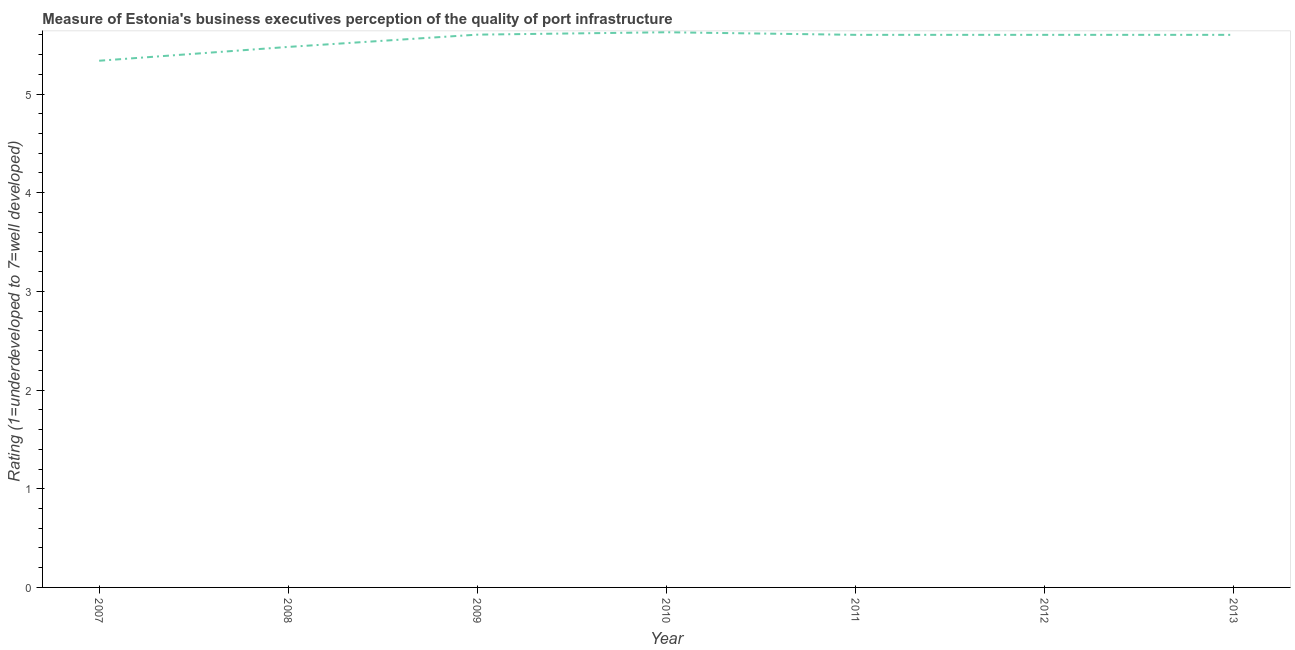What is the rating measuring quality of port infrastructure in 2010?
Offer a terse response. 5.63. Across all years, what is the maximum rating measuring quality of port infrastructure?
Ensure brevity in your answer.  5.63. Across all years, what is the minimum rating measuring quality of port infrastructure?
Offer a very short reply. 5.34. In which year was the rating measuring quality of port infrastructure maximum?
Keep it short and to the point. 2010. In which year was the rating measuring quality of port infrastructure minimum?
Your answer should be very brief. 2007. What is the sum of the rating measuring quality of port infrastructure?
Provide a short and direct response. 38.84. What is the difference between the rating measuring quality of port infrastructure in 2007 and 2012?
Provide a short and direct response. -0.26. What is the average rating measuring quality of port infrastructure per year?
Offer a terse response. 5.55. In how many years, is the rating measuring quality of port infrastructure greater than 1.4 ?
Your answer should be very brief. 7. What is the ratio of the rating measuring quality of port infrastructure in 2009 to that in 2013?
Offer a terse response. 1. Is the rating measuring quality of port infrastructure in 2007 less than that in 2009?
Your response must be concise. Yes. What is the difference between the highest and the second highest rating measuring quality of port infrastructure?
Your response must be concise. 0.02. Is the sum of the rating measuring quality of port infrastructure in 2008 and 2013 greater than the maximum rating measuring quality of port infrastructure across all years?
Provide a succinct answer. Yes. What is the difference between the highest and the lowest rating measuring quality of port infrastructure?
Offer a very short reply. 0.29. In how many years, is the rating measuring quality of port infrastructure greater than the average rating measuring quality of port infrastructure taken over all years?
Provide a short and direct response. 5. Does the rating measuring quality of port infrastructure monotonically increase over the years?
Ensure brevity in your answer.  No. How many lines are there?
Keep it short and to the point. 1. What is the difference between two consecutive major ticks on the Y-axis?
Keep it short and to the point. 1. Does the graph contain grids?
Your response must be concise. No. What is the title of the graph?
Your answer should be compact. Measure of Estonia's business executives perception of the quality of port infrastructure. What is the label or title of the Y-axis?
Your answer should be compact. Rating (1=underdeveloped to 7=well developed) . What is the Rating (1=underdeveloped to 7=well developed)  in 2007?
Give a very brief answer. 5.34. What is the Rating (1=underdeveloped to 7=well developed)  in 2008?
Offer a very short reply. 5.48. What is the Rating (1=underdeveloped to 7=well developed)  of 2009?
Your answer should be very brief. 5.6. What is the Rating (1=underdeveloped to 7=well developed)  of 2010?
Ensure brevity in your answer.  5.63. What is the Rating (1=underdeveloped to 7=well developed)  in 2011?
Offer a very short reply. 5.6. What is the Rating (1=underdeveloped to 7=well developed)  of 2012?
Keep it short and to the point. 5.6. What is the difference between the Rating (1=underdeveloped to 7=well developed)  in 2007 and 2008?
Your answer should be compact. -0.14. What is the difference between the Rating (1=underdeveloped to 7=well developed)  in 2007 and 2009?
Your response must be concise. -0.26. What is the difference between the Rating (1=underdeveloped to 7=well developed)  in 2007 and 2010?
Your answer should be very brief. -0.29. What is the difference between the Rating (1=underdeveloped to 7=well developed)  in 2007 and 2011?
Your answer should be very brief. -0.26. What is the difference between the Rating (1=underdeveloped to 7=well developed)  in 2007 and 2012?
Offer a terse response. -0.26. What is the difference between the Rating (1=underdeveloped to 7=well developed)  in 2007 and 2013?
Your response must be concise. -0.26. What is the difference between the Rating (1=underdeveloped to 7=well developed)  in 2008 and 2009?
Make the answer very short. -0.12. What is the difference between the Rating (1=underdeveloped to 7=well developed)  in 2008 and 2010?
Ensure brevity in your answer.  -0.15. What is the difference between the Rating (1=underdeveloped to 7=well developed)  in 2008 and 2011?
Offer a very short reply. -0.12. What is the difference between the Rating (1=underdeveloped to 7=well developed)  in 2008 and 2012?
Provide a succinct answer. -0.12. What is the difference between the Rating (1=underdeveloped to 7=well developed)  in 2008 and 2013?
Your answer should be compact. -0.12. What is the difference between the Rating (1=underdeveloped to 7=well developed)  in 2009 and 2010?
Provide a short and direct response. -0.02. What is the difference between the Rating (1=underdeveloped to 7=well developed)  in 2009 and 2011?
Offer a very short reply. 0. What is the difference between the Rating (1=underdeveloped to 7=well developed)  in 2009 and 2012?
Ensure brevity in your answer.  0. What is the difference between the Rating (1=underdeveloped to 7=well developed)  in 2009 and 2013?
Your answer should be very brief. 0. What is the difference between the Rating (1=underdeveloped to 7=well developed)  in 2010 and 2011?
Offer a terse response. 0.03. What is the difference between the Rating (1=underdeveloped to 7=well developed)  in 2010 and 2012?
Your answer should be compact. 0.03. What is the difference between the Rating (1=underdeveloped to 7=well developed)  in 2010 and 2013?
Offer a very short reply. 0.03. What is the difference between the Rating (1=underdeveloped to 7=well developed)  in 2011 and 2013?
Keep it short and to the point. 0. What is the difference between the Rating (1=underdeveloped to 7=well developed)  in 2012 and 2013?
Your answer should be very brief. 0. What is the ratio of the Rating (1=underdeveloped to 7=well developed)  in 2007 to that in 2008?
Your answer should be compact. 0.97. What is the ratio of the Rating (1=underdeveloped to 7=well developed)  in 2007 to that in 2009?
Your response must be concise. 0.95. What is the ratio of the Rating (1=underdeveloped to 7=well developed)  in 2007 to that in 2010?
Your answer should be compact. 0.95. What is the ratio of the Rating (1=underdeveloped to 7=well developed)  in 2007 to that in 2011?
Give a very brief answer. 0.95. What is the ratio of the Rating (1=underdeveloped to 7=well developed)  in 2007 to that in 2012?
Your answer should be very brief. 0.95. What is the ratio of the Rating (1=underdeveloped to 7=well developed)  in 2007 to that in 2013?
Your answer should be compact. 0.95. What is the ratio of the Rating (1=underdeveloped to 7=well developed)  in 2008 to that in 2009?
Provide a succinct answer. 0.98. What is the ratio of the Rating (1=underdeveloped to 7=well developed)  in 2008 to that in 2012?
Offer a very short reply. 0.98. What is the ratio of the Rating (1=underdeveloped to 7=well developed)  in 2008 to that in 2013?
Provide a short and direct response. 0.98. What is the ratio of the Rating (1=underdeveloped to 7=well developed)  in 2009 to that in 2010?
Make the answer very short. 1. What is the ratio of the Rating (1=underdeveloped to 7=well developed)  in 2009 to that in 2011?
Provide a short and direct response. 1. What is the ratio of the Rating (1=underdeveloped to 7=well developed)  in 2009 to that in 2012?
Make the answer very short. 1. What is the ratio of the Rating (1=underdeveloped to 7=well developed)  in 2009 to that in 2013?
Offer a very short reply. 1. What is the ratio of the Rating (1=underdeveloped to 7=well developed)  in 2010 to that in 2013?
Give a very brief answer. 1. What is the ratio of the Rating (1=underdeveloped to 7=well developed)  in 2011 to that in 2012?
Make the answer very short. 1. What is the ratio of the Rating (1=underdeveloped to 7=well developed)  in 2012 to that in 2013?
Ensure brevity in your answer.  1. 